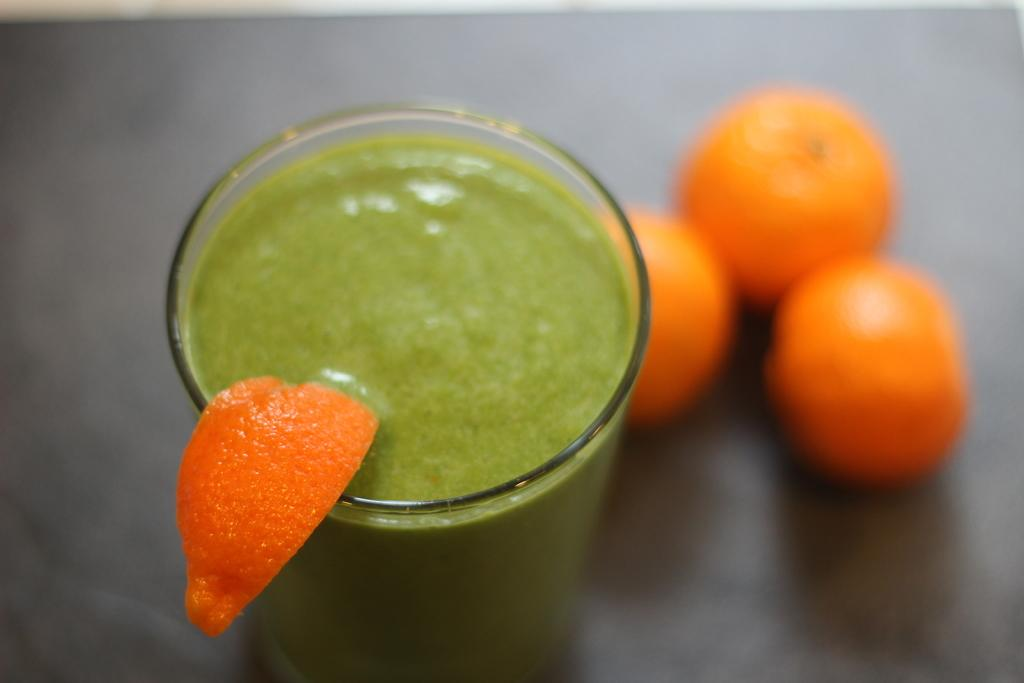What is in the glass that is visible in the image? There is a glass in the image, and the liquid in the glass is green. What is placed on top of the glass? There is an orange slice on the glass. How many oranges are present in the image? There are three oranges in the image. What does the man's grandmother say about the quarter she found in the image? There is no man, grandmother, or quarter present in the image. 